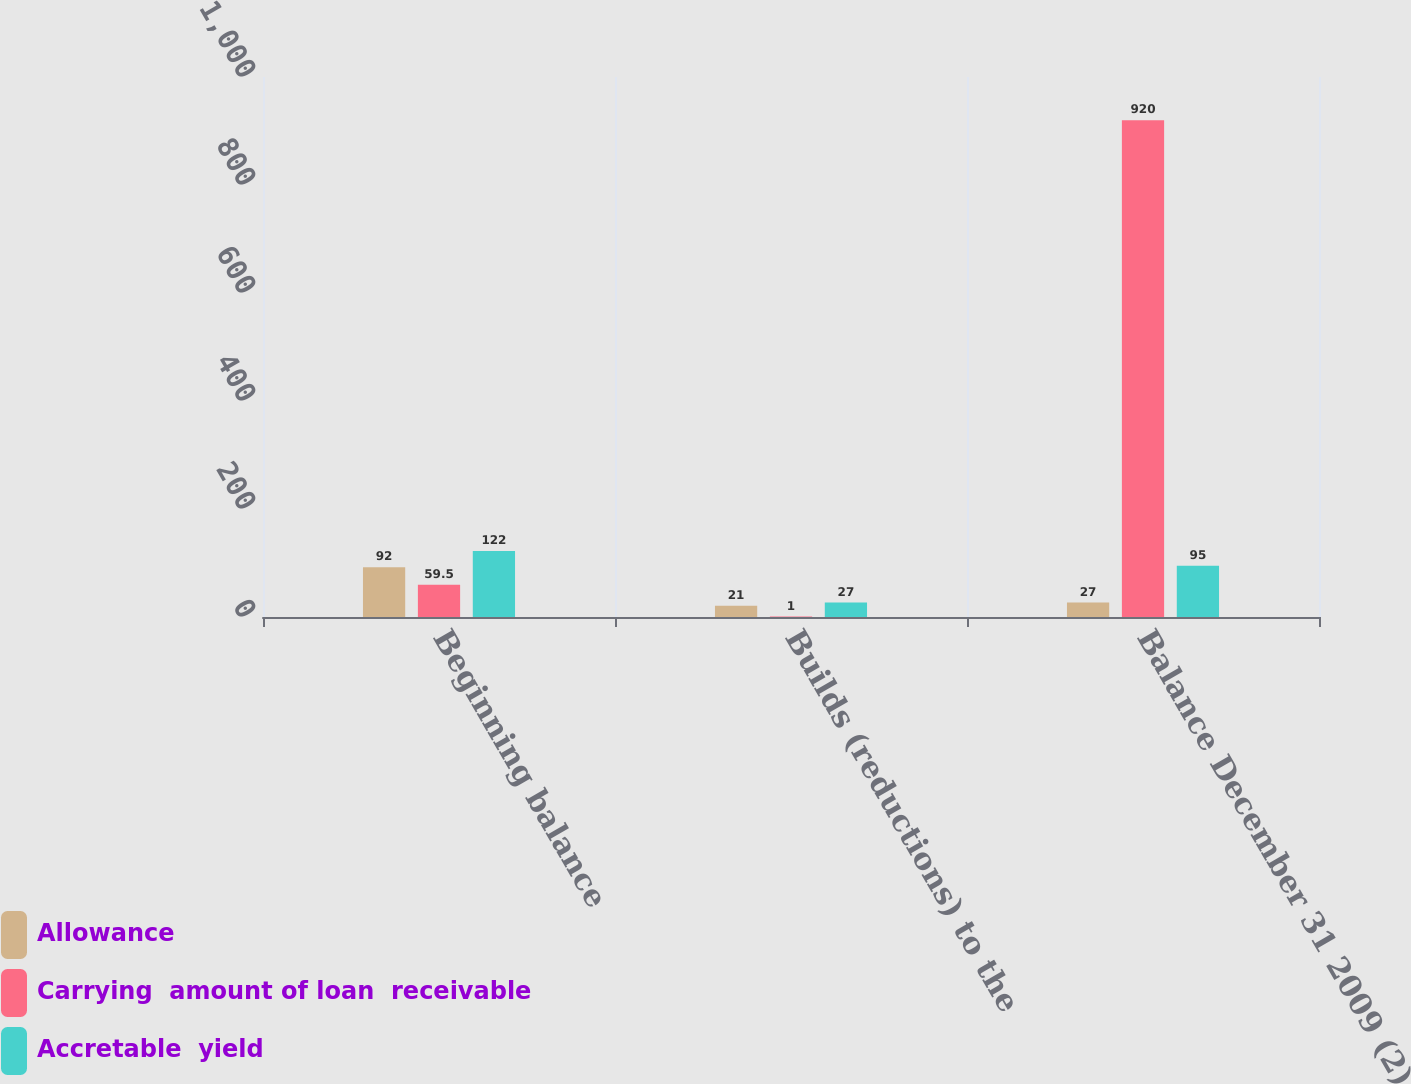<chart> <loc_0><loc_0><loc_500><loc_500><stacked_bar_chart><ecel><fcel>Beginning balance<fcel>Builds (reductions) to the<fcel>Balance December 31 2009 (2)<nl><fcel>Allowance<fcel>92<fcel>21<fcel>27<nl><fcel>Carrying  amount of loan  receivable<fcel>59.5<fcel>1<fcel>920<nl><fcel>Accretable  yield<fcel>122<fcel>27<fcel>95<nl></chart> 